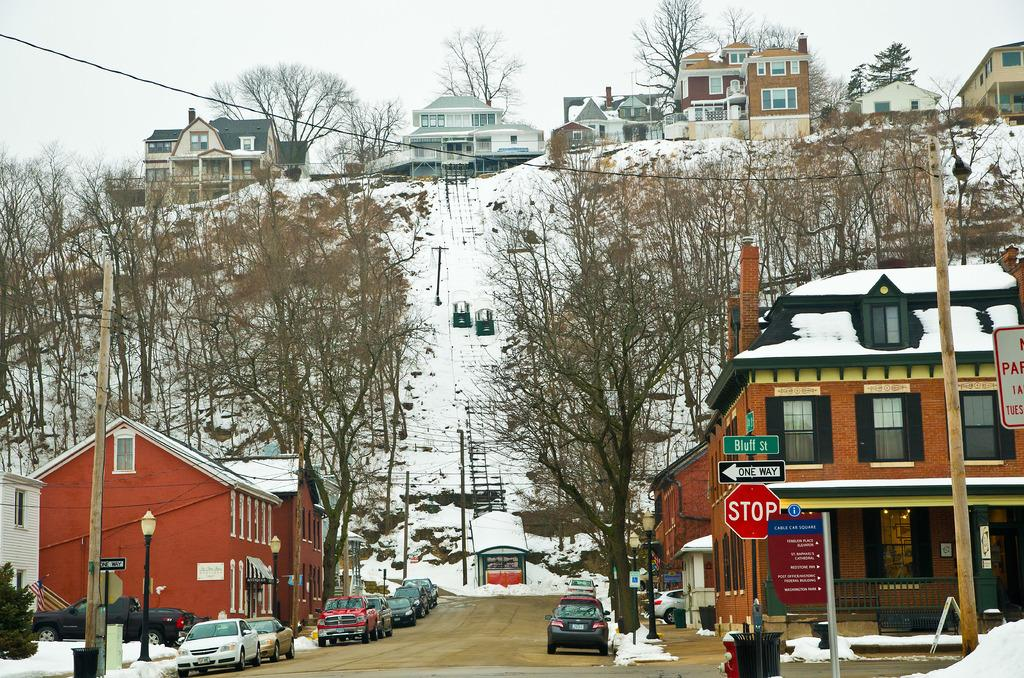What is the main feature of the image? There is a road at the center of the image. What can be seen traveling on the road? There are cars in the image. What type of vegetation is present in the image? There are trees in the image. What structures are visible on both sides of the road? There are buildings at both sides of the image. What weather condition is depicted in the image? There is snow visible in the image. How many boats are visible in the image? There are no boats present in the image. What type of kite is being flown by the person in the image? There is no person or kite present in the image. 